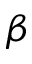Convert formula to latex. <formula><loc_0><loc_0><loc_500><loc_500>\beta</formula> 